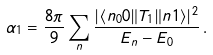<formula> <loc_0><loc_0><loc_500><loc_500>\alpha _ { 1 } = \frac { 8 \pi } { 9 } \sum _ { n } \frac { | \langle n _ { 0 } 0 \| T _ { 1 } \| n 1 \rangle | ^ { 2 } } { E _ { n } - E _ { 0 } } \, .</formula> 